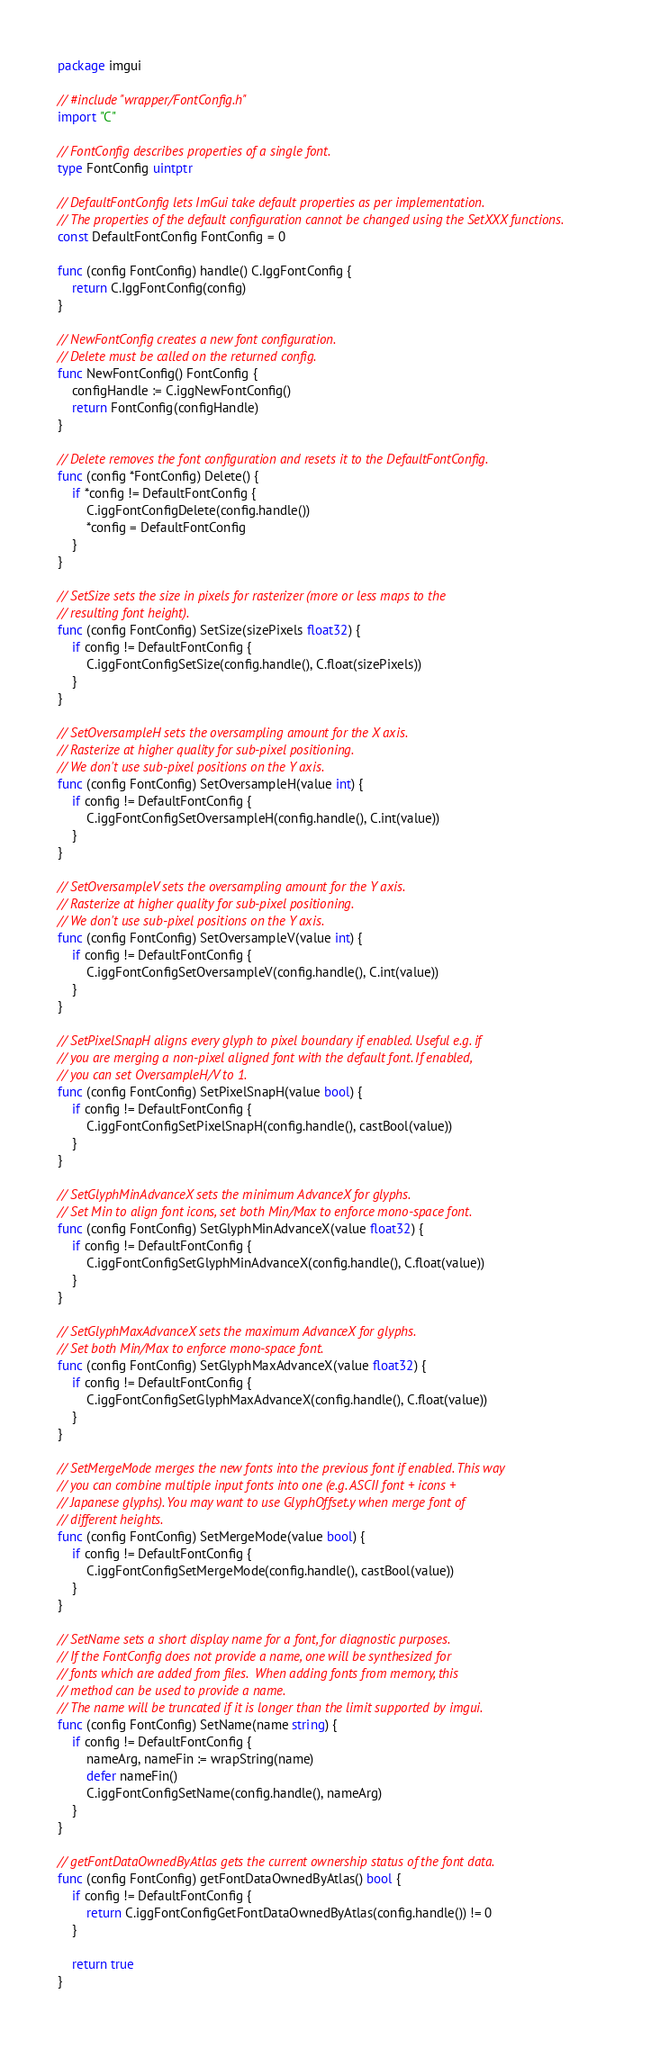<code> <loc_0><loc_0><loc_500><loc_500><_Go_>package imgui

// #include "wrapper/FontConfig.h"
import "C"

// FontConfig describes properties of a single font.
type FontConfig uintptr

// DefaultFontConfig lets ImGui take default properties as per implementation.
// The properties of the default configuration cannot be changed using the SetXXX functions.
const DefaultFontConfig FontConfig = 0

func (config FontConfig) handle() C.IggFontConfig {
	return C.IggFontConfig(config)
}

// NewFontConfig creates a new font configuration.
// Delete must be called on the returned config.
func NewFontConfig() FontConfig {
	configHandle := C.iggNewFontConfig()
	return FontConfig(configHandle)
}

// Delete removes the font configuration and resets it to the DefaultFontConfig.
func (config *FontConfig) Delete() {
	if *config != DefaultFontConfig {
		C.iggFontConfigDelete(config.handle())
		*config = DefaultFontConfig
	}
}

// SetSize sets the size in pixels for rasterizer (more or less maps to the
// resulting font height).
func (config FontConfig) SetSize(sizePixels float32) {
	if config != DefaultFontConfig {
		C.iggFontConfigSetSize(config.handle(), C.float(sizePixels))
	}
}

// SetOversampleH sets the oversampling amount for the X axis.
// Rasterize at higher quality for sub-pixel positioning.
// We don't use sub-pixel positions on the Y axis.
func (config FontConfig) SetOversampleH(value int) {
	if config != DefaultFontConfig {
		C.iggFontConfigSetOversampleH(config.handle(), C.int(value))
	}
}

// SetOversampleV sets the oversampling amount for the Y axis.
// Rasterize at higher quality for sub-pixel positioning.
// We don't use sub-pixel positions on the Y axis.
func (config FontConfig) SetOversampleV(value int) {
	if config != DefaultFontConfig {
		C.iggFontConfigSetOversampleV(config.handle(), C.int(value))
	}
}

// SetPixelSnapH aligns every glyph to pixel boundary if enabled. Useful e.g. if
// you are merging a non-pixel aligned font with the default font. If enabled,
// you can set OversampleH/V to 1.
func (config FontConfig) SetPixelSnapH(value bool) {
	if config != DefaultFontConfig {
		C.iggFontConfigSetPixelSnapH(config.handle(), castBool(value))
	}
}

// SetGlyphMinAdvanceX sets the minimum AdvanceX for glyphs.
// Set Min to align font icons, set both Min/Max to enforce mono-space font.
func (config FontConfig) SetGlyphMinAdvanceX(value float32) {
	if config != DefaultFontConfig {
		C.iggFontConfigSetGlyphMinAdvanceX(config.handle(), C.float(value))
	}
}

// SetGlyphMaxAdvanceX sets the maximum AdvanceX for glyphs.
// Set both Min/Max to enforce mono-space font.
func (config FontConfig) SetGlyphMaxAdvanceX(value float32) {
	if config != DefaultFontConfig {
		C.iggFontConfigSetGlyphMaxAdvanceX(config.handle(), C.float(value))
	}
}

// SetMergeMode merges the new fonts into the previous font if enabled. This way
// you can combine multiple input fonts into one (e.g. ASCII font + icons +
// Japanese glyphs). You may want to use GlyphOffset.y when merge font of
// different heights.
func (config FontConfig) SetMergeMode(value bool) {
	if config != DefaultFontConfig {
		C.iggFontConfigSetMergeMode(config.handle(), castBool(value))
	}
}

// SetName sets a short display name for a font, for diagnostic purposes.
// If the FontConfig does not provide a name, one will be synthesized for
// fonts which are added from files.  When adding fonts from memory, this
// method can be used to provide a name.
// The name will be truncated if it is longer than the limit supported by imgui.
func (config FontConfig) SetName(name string) {
	if config != DefaultFontConfig {
		nameArg, nameFin := wrapString(name)
		defer nameFin()
		C.iggFontConfigSetName(config.handle(), nameArg)
	}
}

// getFontDataOwnedByAtlas gets the current ownership status of the font data.
func (config FontConfig) getFontDataOwnedByAtlas() bool {
	if config != DefaultFontConfig {
		return C.iggFontConfigGetFontDataOwnedByAtlas(config.handle()) != 0
	}

	return true
}
</code> 